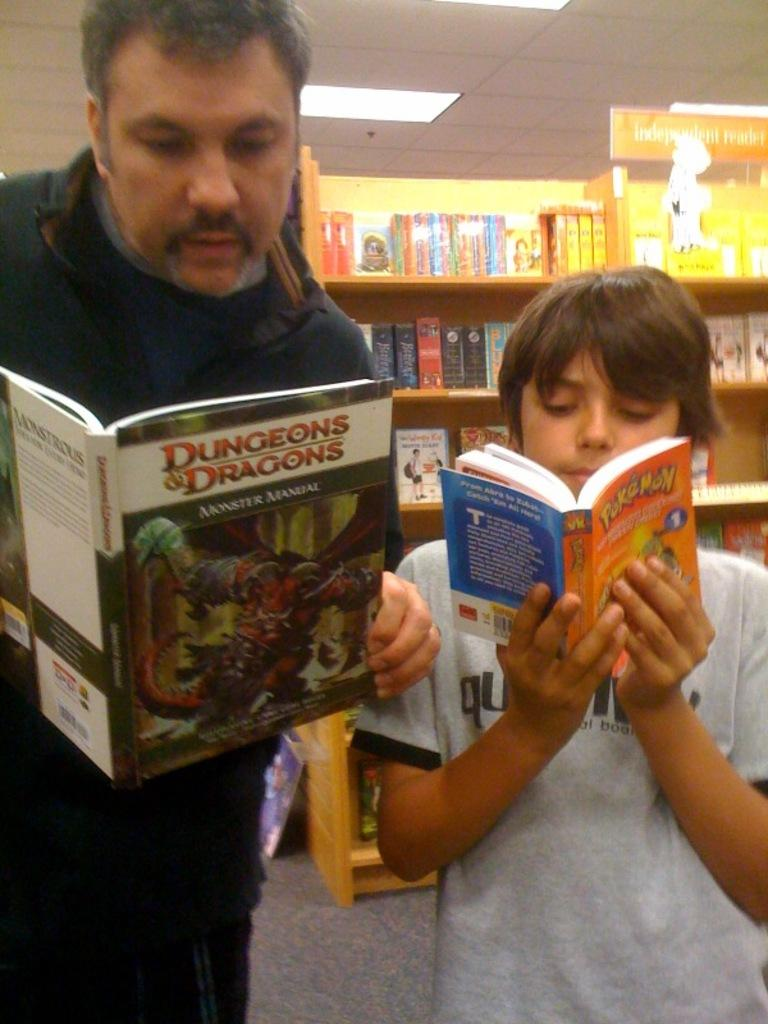<image>
Offer a succinct explanation of the picture presented. Two people read books together, one reading Pokemon, while the other Dungeons and Dragons. 